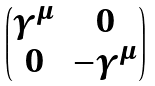Convert formula to latex. <formula><loc_0><loc_0><loc_500><loc_500>\begin{pmatrix} \gamma ^ { \mu } & 0 \\ 0 & - \gamma ^ { \mu } \end{pmatrix}</formula> 